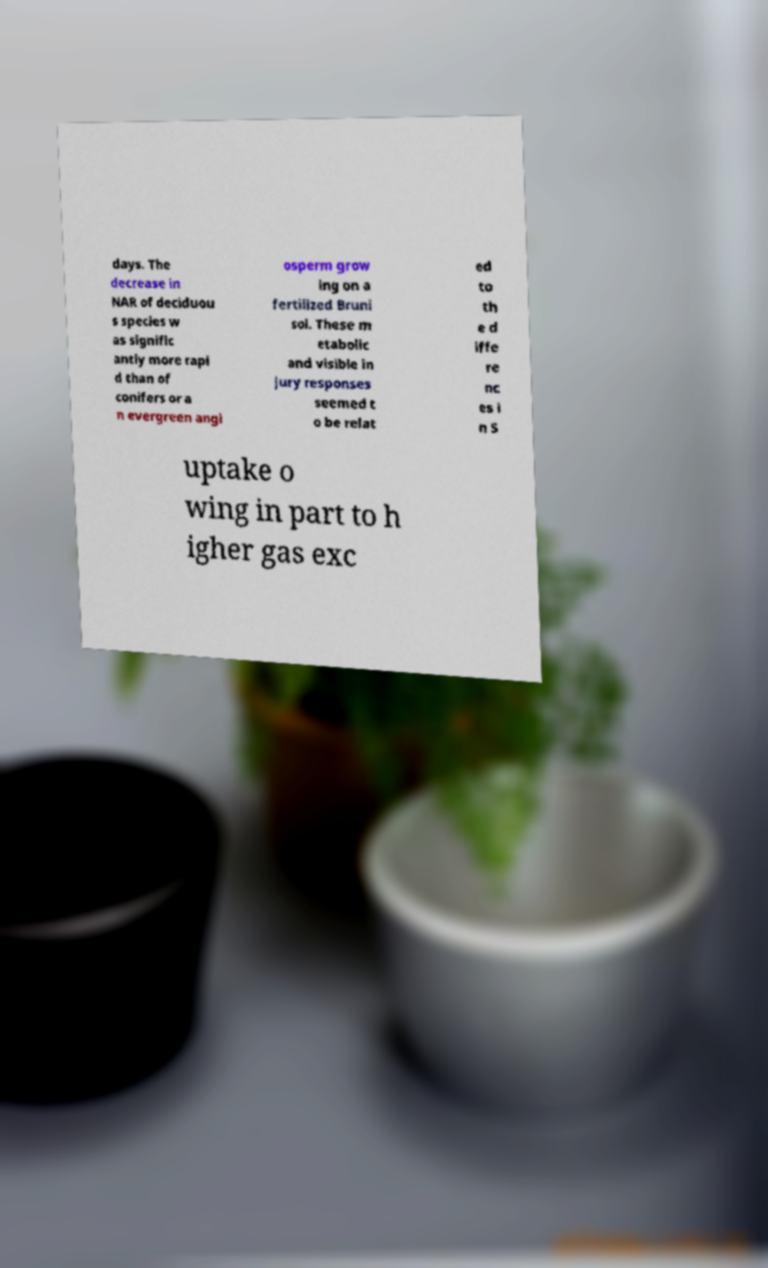Can you read and provide the text displayed in the image?This photo seems to have some interesting text. Can you extract and type it out for me? days. The decrease in NAR of deciduou s species w as signific antly more rapi d than of conifers or a n evergreen angi osperm grow ing on a fertilized Bruni sol. These m etabolic and visible in jury responses seemed t o be relat ed to th e d iffe re nc es i n S uptake o wing in part to h igher gas exc 